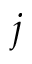<formula> <loc_0><loc_0><loc_500><loc_500>j</formula> 